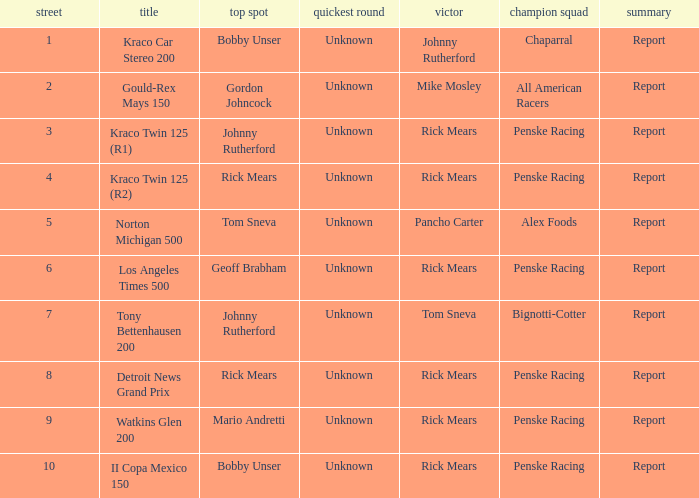The winning team of the race, los angeles times 500 is who? Penske Racing. Would you be able to parse every entry in this table? {'header': ['street', 'title', 'top spot', 'quickest round', 'victor', 'champion squad', 'summary'], 'rows': [['1', 'Kraco Car Stereo 200', 'Bobby Unser', 'Unknown', 'Johnny Rutherford', 'Chaparral', 'Report'], ['2', 'Gould-Rex Mays 150', 'Gordon Johncock', 'Unknown', 'Mike Mosley', 'All American Racers', 'Report'], ['3', 'Kraco Twin 125 (R1)', 'Johnny Rutherford', 'Unknown', 'Rick Mears', 'Penske Racing', 'Report'], ['4', 'Kraco Twin 125 (R2)', 'Rick Mears', 'Unknown', 'Rick Mears', 'Penske Racing', 'Report'], ['5', 'Norton Michigan 500', 'Tom Sneva', 'Unknown', 'Pancho Carter', 'Alex Foods', 'Report'], ['6', 'Los Angeles Times 500', 'Geoff Brabham', 'Unknown', 'Rick Mears', 'Penske Racing', 'Report'], ['7', 'Tony Bettenhausen 200', 'Johnny Rutherford', 'Unknown', 'Tom Sneva', 'Bignotti-Cotter', 'Report'], ['8', 'Detroit News Grand Prix', 'Rick Mears', 'Unknown', 'Rick Mears', 'Penske Racing', 'Report'], ['9', 'Watkins Glen 200', 'Mario Andretti', 'Unknown', 'Rick Mears', 'Penske Racing', 'Report'], ['10', 'II Copa Mexico 150', 'Bobby Unser', 'Unknown', 'Rick Mears', 'Penske Racing', 'Report']]} 